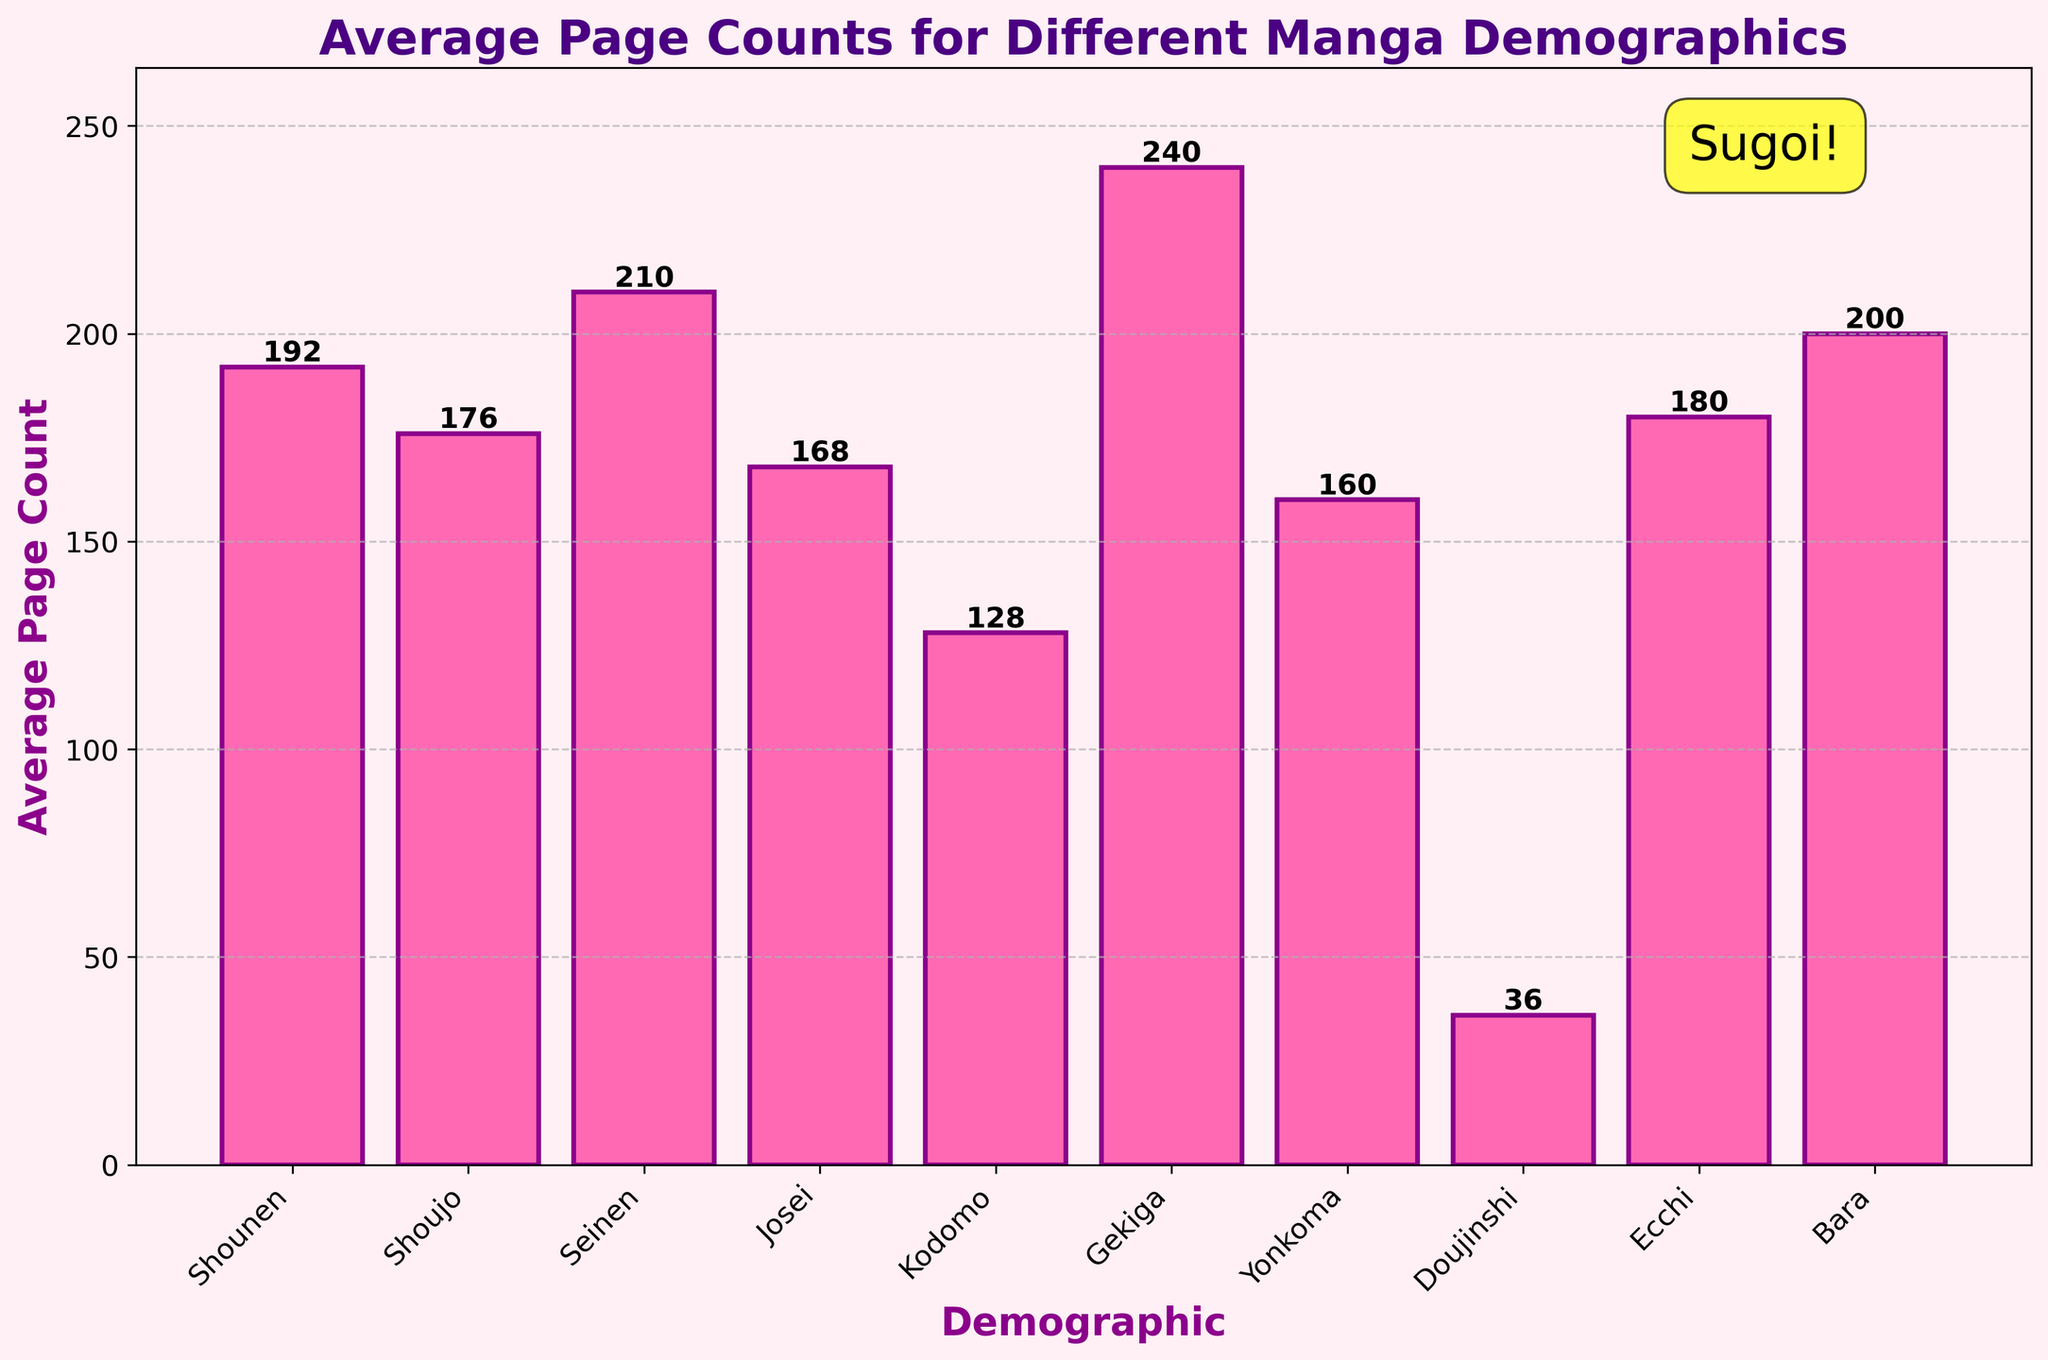What is the demographic with the highest average page count? The demographic with the highest average page count is the one with the tallest bar in the chart. Gekiga has the tallest bar, indicating it has the highest average page count.
Answer: Gekiga Which demographic has the lowest average page count? The demographic with the lowest average page count is the one with the shortest bar in the chart. Doujinshi has the shortest bar, indicating it has the lowest average page count.
Answer: Doujinshi How much more average pages does Seinen have compared to Shoujo? To find the difference in average page counts between Seinen and Shoujo, subtract the average page count of Shoujo from that of Seinen: 210 - 176 = 34.
Answer: 34 pages What are the average page counts for Kodomo and Bara combined? To find the combined average page count for Kodomo and Bara, add their respective average page counts: 128 + 200 = 328.
Answer: 328 pages Which demographics have an average page count above 180? The demographics with average page counts above 180 are the ones with bars taller than the 180 mark on the y-axis. These are Seinen, Gekiga, and Bara.
Answer: Seinen, Gekiga, Bara Compared to Yonkoma, how many more average pages does Seinen have? To find the difference in average page counts between Seinen and Yonkoma, subtract the average page count of Yonkoma from that of Seinen: 210 - 160 = 50.
Answer: 50 pages What is the median average page count among all demographics? List all the average page counts from the chart in ascending order: 36, 128, 160, 168, 176, 180, 192, 200, 210, 240. The median is the middle value. With 10 numbers, the median is the average of the 5th and 6th values: (176 + 180) / 2 = 178.
Answer: 178 pages If a new demographic had an average page count equal to the mean of Yonkoma and Ecchi, what would that page count be? To find the average of Yonkoma and Ecchi's page counts, add them and divide by 2: (160 + 180) / 2 = 170.
Answer: 170 pages 